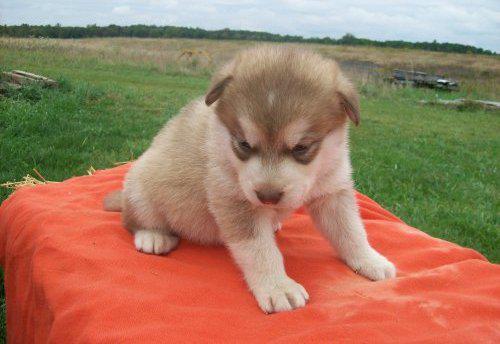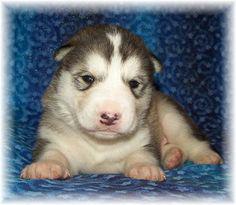The first image is the image on the left, the second image is the image on the right. Examine the images to the left and right. Is the description "One image shows a reclining mother dog with her head on the left, nursing multiple puppies with their tails toward the camera." accurate? Answer yes or no. No. The first image is the image on the left, the second image is the image on the right. Examine the images to the left and right. Is the description "The left and right image contains the same number of husky puppies." accurate? Answer yes or no. Yes. 